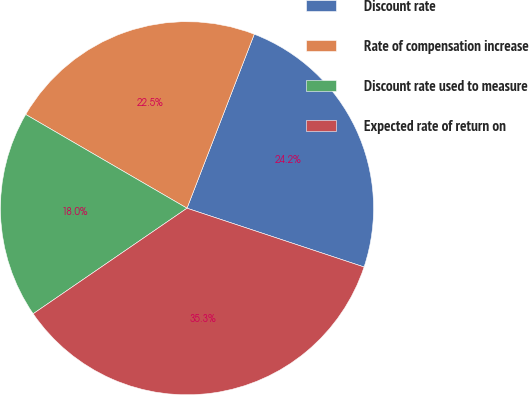<chart> <loc_0><loc_0><loc_500><loc_500><pie_chart><fcel>Discount rate<fcel>Rate of compensation increase<fcel>Discount rate used to measure<fcel>Expected rate of return on<nl><fcel>24.23%<fcel>22.49%<fcel>17.95%<fcel>35.33%<nl></chart> 